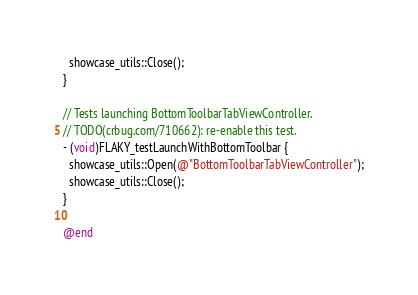<code> <loc_0><loc_0><loc_500><loc_500><_ObjectiveC_>  showcase_utils::Close();
}

// Tests launching BottomToolbarTabViewController.
// TODO(crbug.com/710662): re-enable this test.
- (void)FLAKY_testLaunchWithBottomToolbar {
  showcase_utils::Open(@"BottomToolbarTabViewController");
  showcase_utils::Close();
}

@end
</code> 